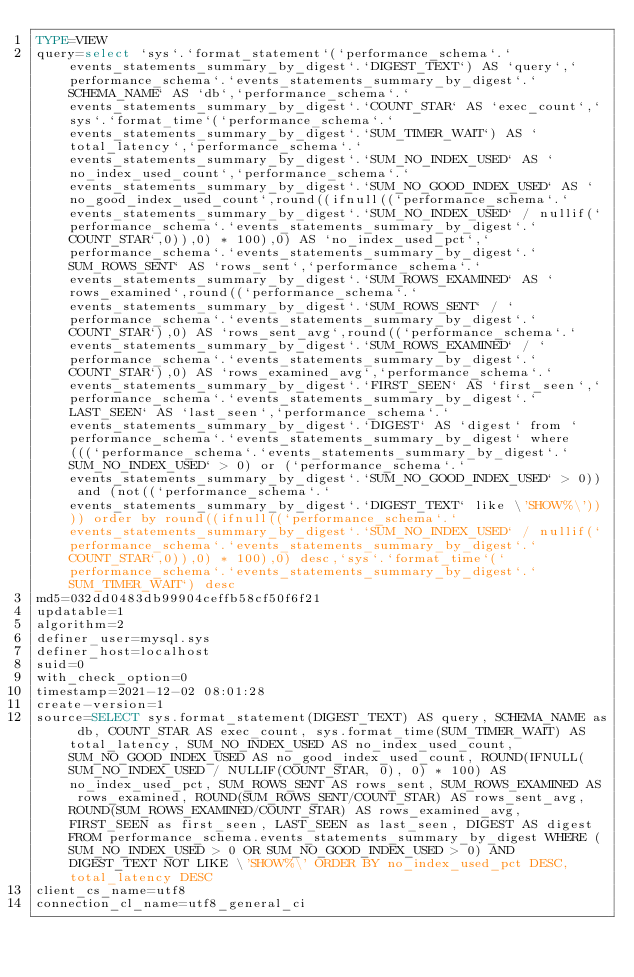Convert code to text. <code><loc_0><loc_0><loc_500><loc_500><_VisualBasic_>TYPE=VIEW
query=select `sys`.`format_statement`(`performance_schema`.`events_statements_summary_by_digest`.`DIGEST_TEXT`) AS `query`,`performance_schema`.`events_statements_summary_by_digest`.`SCHEMA_NAME` AS `db`,`performance_schema`.`events_statements_summary_by_digest`.`COUNT_STAR` AS `exec_count`,`sys`.`format_time`(`performance_schema`.`events_statements_summary_by_digest`.`SUM_TIMER_WAIT`) AS `total_latency`,`performance_schema`.`events_statements_summary_by_digest`.`SUM_NO_INDEX_USED` AS `no_index_used_count`,`performance_schema`.`events_statements_summary_by_digest`.`SUM_NO_GOOD_INDEX_USED` AS `no_good_index_used_count`,round((ifnull((`performance_schema`.`events_statements_summary_by_digest`.`SUM_NO_INDEX_USED` / nullif(`performance_schema`.`events_statements_summary_by_digest`.`COUNT_STAR`,0)),0) * 100),0) AS `no_index_used_pct`,`performance_schema`.`events_statements_summary_by_digest`.`SUM_ROWS_SENT` AS `rows_sent`,`performance_schema`.`events_statements_summary_by_digest`.`SUM_ROWS_EXAMINED` AS `rows_examined`,round((`performance_schema`.`events_statements_summary_by_digest`.`SUM_ROWS_SENT` / `performance_schema`.`events_statements_summary_by_digest`.`COUNT_STAR`),0) AS `rows_sent_avg`,round((`performance_schema`.`events_statements_summary_by_digest`.`SUM_ROWS_EXAMINED` / `performance_schema`.`events_statements_summary_by_digest`.`COUNT_STAR`),0) AS `rows_examined_avg`,`performance_schema`.`events_statements_summary_by_digest`.`FIRST_SEEN` AS `first_seen`,`performance_schema`.`events_statements_summary_by_digest`.`LAST_SEEN` AS `last_seen`,`performance_schema`.`events_statements_summary_by_digest`.`DIGEST` AS `digest` from `performance_schema`.`events_statements_summary_by_digest` where (((`performance_schema`.`events_statements_summary_by_digest`.`SUM_NO_INDEX_USED` > 0) or (`performance_schema`.`events_statements_summary_by_digest`.`SUM_NO_GOOD_INDEX_USED` > 0)) and (not((`performance_schema`.`events_statements_summary_by_digest`.`DIGEST_TEXT` like \'SHOW%\')))) order by round((ifnull((`performance_schema`.`events_statements_summary_by_digest`.`SUM_NO_INDEX_USED` / nullif(`performance_schema`.`events_statements_summary_by_digest`.`COUNT_STAR`,0)),0) * 100),0) desc,`sys`.`format_time`(`performance_schema`.`events_statements_summary_by_digest`.`SUM_TIMER_WAIT`) desc
md5=032dd0483db99904ceffb58cf50f6f21
updatable=1
algorithm=2
definer_user=mysql.sys
definer_host=localhost
suid=0
with_check_option=0
timestamp=2021-12-02 08:01:28
create-version=1
source=SELECT sys.format_statement(DIGEST_TEXT) AS query, SCHEMA_NAME as db, COUNT_STAR AS exec_count, sys.format_time(SUM_TIMER_WAIT) AS total_latency, SUM_NO_INDEX_USED AS no_index_used_count, SUM_NO_GOOD_INDEX_USED AS no_good_index_used_count, ROUND(IFNULL(SUM_NO_INDEX_USED / NULLIF(COUNT_STAR, 0), 0) * 100) AS no_index_used_pct, SUM_ROWS_SENT AS rows_sent, SUM_ROWS_EXAMINED AS rows_examined, ROUND(SUM_ROWS_SENT/COUNT_STAR) AS rows_sent_avg, ROUND(SUM_ROWS_EXAMINED/COUNT_STAR) AS rows_examined_avg, FIRST_SEEN as first_seen, LAST_SEEN as last_seen, DIGEST AS digest FROM performance_schema.events_statements_summary_by_digest WHERE (SUM_NO_INDEX_USED > 0 OR SUM_NO_GOOD_INDEX_USED > 0) AND DIGEST_TEXT NOT LIKE \'SHOW%\' ORDER BY no_index_used_pct DESC, total_latency DESC
client_cs_name=utf8
connection_cl_name=utf8_general_ci</code> 